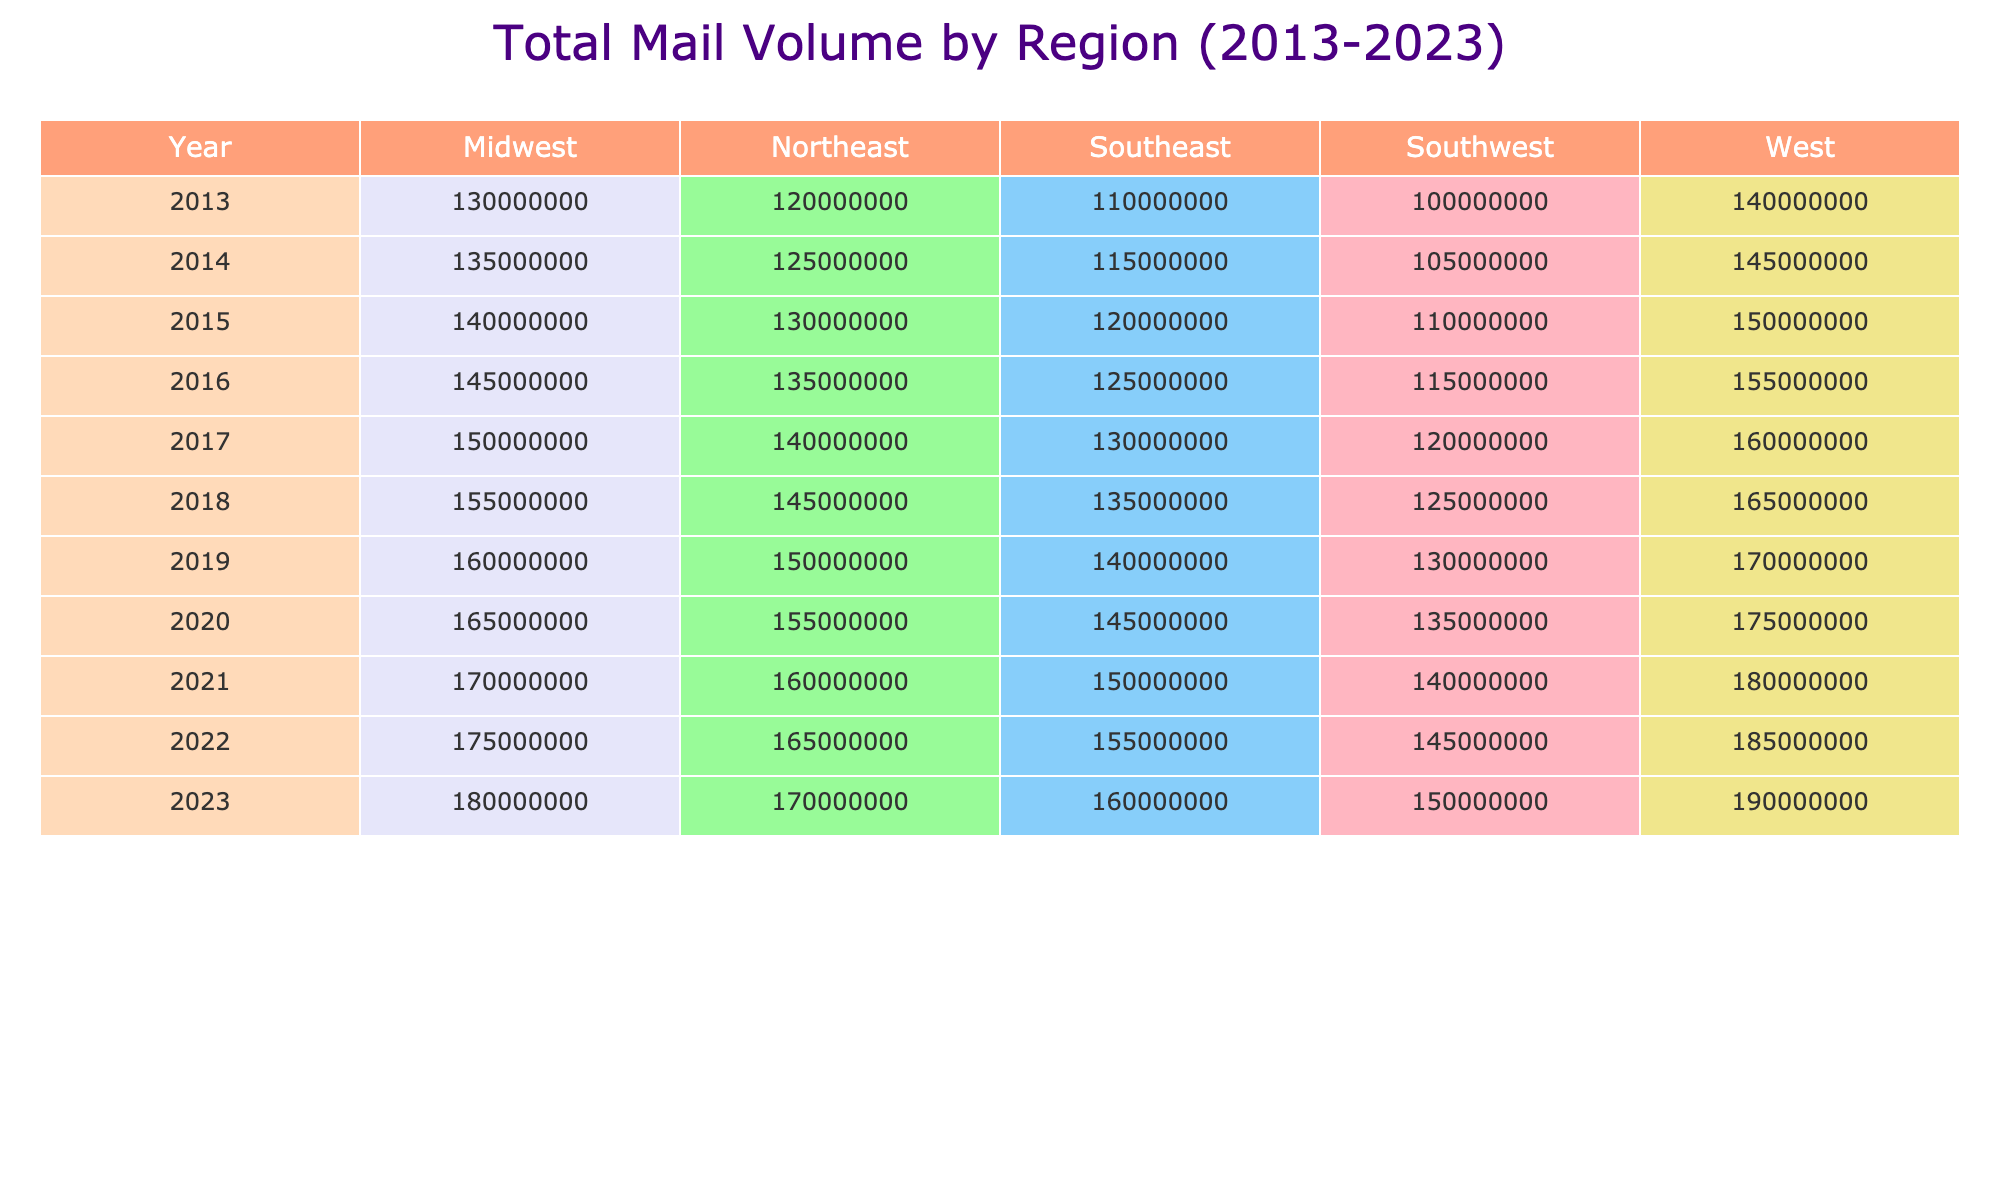What was the total mail volume in the Midwest in 2020? Referring to the table, under the Midwest region and the year 2020, the total mail volume is listed as 165,000,000.
Answer: 165000000 Which region had the highest total mail volume in 2023? Looking at the table, in 2023, the total mail volumes for each region are: Northeast: 170,000,000, Southeast: 160,000,000, Midwest: 180,000,000, West: 190,000,000, Southwest: 150,000,000. The West region had the highest total at 190,000,000.
Answer: West What is the average total mail volume in the Northeast from 2013 to 2023? Summing the total mail volumes in the Northeast from 2013 to 2023 gives: 120,000,000 + 125,000,000 + 130,000,000 + 135,000,000 + 140,000,000 + 145,000,000 + 150,000,000 + 155,000,000 + 160,000,000 + 165,000,000 + 170,000,000 = 1,600,000,000. Since there are 11 years, the average is 1,600,000,000 / 11 ≈ 145,454,545.
Answer: Approximately 145454545 Did the total mail volume decrease in the Southeast from 2018 to 2019? In the Southeast region, the total mail volume for 2018 is 135,000,000 and for 2019 is 140,000,000. Since 140,000,000 is greater than 135,000,000, the volume did not decrease.
Answer: No What is the difference in total mail volume between the Midwest and the Northeast in 2022? In 2022, the Northeast had a total mail volume of 165,000,000 and the Midwest had a total of 175,000,000. The difference is 175,000,000 - 165,000,000 = 10,000,000.
Answer: 10000000 Which region consistently increased its total mail volume every year from 2013 to 2023? By reviewing the table, we see all regions have increasing total mail volumes year-over-year from 2013 through 2023. Hence, the answer is all regions show this trend.
Answer: Yes, all regions What was the e-commerce mail volume in the Northeast in 2021 compared to 2023? In 2021, the e-commerce mail volume in the Northeast was 23000000, and by 2023, it increased to 25000000. Thus, this shows an increase of 2000000 from 2021 to 2023.
Answer: Increased by 2000000 What was the highest e-commerce mail volume recorded across all regions in 2023? Checking the e-commerce volumes for all regions in 2023 gives: Northeast: 25,000,000, Southeast: 17,000,000, Midwest: 22,000,000, West: 25,000,000, Southwest: 10,000,000. The highest values are 25,000,000 for both the Northeast and West.
Answer: 25000000 Did the total mail volume in the Southwest exceed 120 million in 2021? In 2021, the total mail volume for the Southwest was 140,000,000, which is greater than 120 million, confirming the statement is true.
Answer: Yes What was the total mail volume for the Southeast region in the years 2014 and 2015 combined? Adding the total mail volumes for Southeast in 2014 (115,000,000) and 2015 (120,000,000) gives: 115,000,000 + 120,000,000 = 235,000,000.
Answer: 235000000 